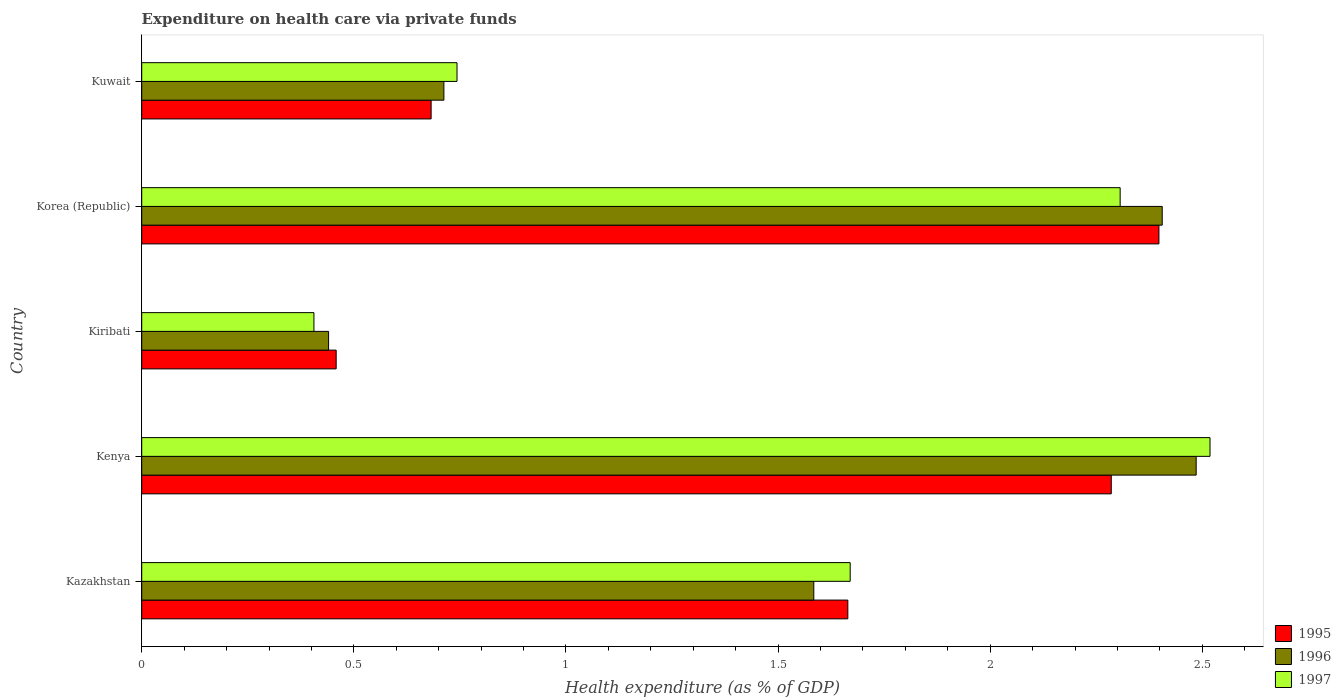How many bars are there on the 2nd tick from the bottom?
Your answer should be very brief. 3. What is the label of the 5th group of bars from the top?
Your answer should be very brief. Kazakhstan. In how many cases, is the number of bars for a given country not equal to the number of legend labels?
Your answer should be very brief. 0. What is the expenditure made on health care in 1997 in Kuwait?
Your response must be concise. 0.74. Across all countries, what is the maximum expenditure made on health care in 1995?
Your answer should be very brief. 2.4. Across all countries, what is the minimum expenditure made on health care in 1997?
Your answer should be compact. 0.41. In which country was the expenditure made on health care in 1996 maximum?
Your answer should be very brief. Kenya. In which country was the expenditure made on health care in 1995 minimum?
Offer a terse response. Kiribati. What is the total expenditure made on health care in 1996 in the graph?
Your answer should be compact. 7.63. What is the difference between the expenditure made on health care in 1996 in Kiribati and that in Kuwait?
Make the answer very short. -0.27. What is the difference between the expenditure made on health care in 1997 in Kazakhstan and the expenditure made on health care in 1995 in Kenya?
Your response must be concise. -0.62. What is the average expenditure made on health care in 1996 per country?
Offer a terse response. 1.53. What is the difference between the expenditure made on health care in 1995 and expenditure made on health care in 1996 in Kazakhstan?
Your answer should be very brief. 0.08. What is the ratio of the expenditure made on health care in 1996 in Korea (Republic) to that in Kuwait?
Your answer should be compact. 3.38. What is the difference between the highest and the second highest expenditure made on health care in 1997?
Ensure brevity in your answer.  0.21. What is the difference between the highest and the lowest expenditure made on health care in 1996?
Your response must be concise. 2.04. What does the 1st bar from the top in Kazakhstan represents?
Give a very brief answer. 1997. Are all the bars in the graph horizontal?
Give a very brief answer. Yes. What is the difference between two consecutive major ticks on the X-axis?
Keep it short and to the point. 0.5. Are the values on the major ticks of X-axis written in scientific E-notation?
Keep it short and to the point. No. Does the graph contain any zero values?
Provide a short and direct response. No. What is the title of the graph?
Your response must be concise. Expenditure on health care via private funds. What is the label or title of the X-axis?
Your answer should be compact. Health expenditure (as % of GDP). What is the Health expenditure (as % of GDP) in 1995 in Kazakhstan?
Your response must be concise. 1.66. What is the Health expenditure (as % of GDP) of 1996 in Kazakhstan?
Provide a short and direct response. 1.58. What is the Health expenditure (as % of GDP) of 1997 in Kazakhstan?
Offer a very short reply. 1.67. What is the Health expenditure (as % of GDP) of 1995 in Kenya?
Provide a succinct answer. 2.29. What is the Health expenditure (as % of GDP) in 1996 in Kenya?
Provide a succinct answer. 2.49. What is the Health expenditure (as % of GDP) in 1997 in Kenya?
Ensure brevity in your answer.  2.52. What is the Health expenditure (as % of GDP) in 1995 in Kiribati?
Make the answer very short. 0.46. What is the Health expenditure (as % of GDP) of 1996 in Kiribati?
Provide a succinct answer. 0.44. What is the Health expenditure (as % of GDP) of 1997 in Kiribati?
Keep it short and to the point. 0.41. What is the Health expenditure (as % of GDP) of 1995 in Korea (Republic)?
Provide a succinct answer. 2.4. What is the Health expenditure (as % of GDP) in 1996 in Korea (Republic)?
Your response must be concise. 2.41. What is the Health expenditure (as % of GDP) in 1997 in Korea (Republic)?
Ensure brevity in your answer.  2.31. What is the Health expenditure (as % of GDP) of 1995 in Kuwait?
Ensure brevity in your answer.  0.68. What is the Health expenditure (as % of GDP) in 1996 in Kuwait?
Your answer should be very brief. 0.71. What is the Health expenditure (as % of GDP) of 1997 in Kuwait?
Your answer should be very brief. 0.74. Across all countries, what is the maximum Health expenditure (as % of GDP) in 1995?
Give a very brief answer. 2.4. Across all countries, what is the maximum Health expenditure (as % of GDP) of 1996?
Your answer should be compact. 2.49. Across all countries, what is the maximum Health expenditure (as % of GDP) in 1997?
Your answer should be very brief. 2.52. Across all countries, what is the minimum Health expenditure (as % of GDP) of 1995?
Keep it short and to the point. 0.46. Across all countries, what is the minimum Health expenditure (as % of GDP) of 1996?
Provide a short and direct response. 0.44. Across all countries, what is the minimum Health expenditure (as % of GDP) of 1997?
Make the answer very short. 0.41. What is the total Health expenditure (as % of GDP) in 1995 in the graph?
Your answer should be very brief. 7.49. What is the total Health expenditure (as % of GDP) of 1996 in the graph?
Your response must be concise. 7.63. What is the total Health expenditure (as % of GDP) in 1997 in the graph?
Keep it short and to the point. 7.64. What is the difference between the Health expenditure (as % of GDP) of 1995 in Kazakhstan and that in Kenya?
Your response must be concise. -0.62. What is the difference between the Health expenditure (as % of GDP) of 1996 in Kazakhstan and that in Kenya?
Ensure brevity in your answer.  -0.9. What is the difference between the Health expenditure (as % of GDP) of 1997 in Kazakhstan and that in Kenya?
Your answer should be very brief. -0.85. What is the difference between the Health expenditure (as % of GDP) of 1995 in Kazakhstan and that in Kiribati?
Offer a terse response. 1.21. What is the difference between the Health expenditure (as % of GDP) in 1996 in Kazakhstan and that in Kiribati?
Make the answer very short. 1.14. What is the difference between the Health expenditure (as % of GDP) in 1997 in Kazakhstan and that in Kiribati?
Provide a succinct answer. 1.26. What is the difference between the Health expenditure (as % of GDP) of 1995 in Kazakhstan and that in Korea (Republic)?
Provide a short and direct response. -0.73. What is the difference between the Health expenditure (as % of GDP) in 1996 in Kazakhstan and that in Korea (Republic)?
Ensure brevity in your answer.  -0.82. What is the difference between the Health expenditure (as % of GDP) in 1997 in Kazakhstan and that in Korea (Republic)?
Your answer should be compact. -0.64. What is the difference between the Health expenditure (as % of GDP) of 1995 in Kazakhstan and that in Kuwait?
Offer a terse response. 0.98. What is the difference between the Health expenditure (as % of GDP) in 1996 in Kazakhstan and that in Kuwait?
Make the answer very short. 0.87. What is the difference between the Health expenditure (as % of GDP) of 1997 in Kazakhstan and that in Kuwait?
Offer a very short reply. 0.93. What is the difference between the Health expenditure (as % of GDP) in 1995 in Kenya and that in Kiribati?
Provide a succinct answer. 1.83. What is the difference between the Health expenditure (as % of GDP) of 1996 in Kenya and that in Kiribati?
Provide a succinct answer. 2.04. What is the difference between the Health expenditure (as % of GDP) in 1997 in Kenya and that in Kiribati?
Your response must be concise. 2.11. What is the difference between the Health expenditure (as % of GDP) of 1995 in Kenya and that in Korea (Republic)?
Offer a terse response. -0.11. What is the difference between the Health expenditure (as % of GDP) of 1997 in Kenya and that in Korea (Republic)?
Make the answer very short. 0.21. What is the difference between the Health expenditure (as % of GDP) in 1995 in Kenya and that in Kuwait?
Keep it short and to the point. 1.6. What is the difference between the Health expenditure (as % of GDP) of 1996 in Kenya and that in Kuwait?
Provide a short and direct response. 1.77. What is the difference between the Health expenditure (as % of GDP) in 1997 in Kenya and that in Kuwait?
Provide a succinct answer. 1.77. What is the difference between the Health expenditure (as % of GDP) in 1995 in Kiribati and that in Korea (Republic)?
Offer a very short reply. -1.94. What is the difference between the Health expenditure (as % of GDP) of 1996 in Kiribati and that in Korea (Republic)?
Your answer should be compact. -1.96. What is the difference between the Health expenditure (as % of GDP) in 1997 in Kiribati and that in Korea (Republic)?
Ensure brevity in your answer.  -1.9. What is the difference between the Health expenditure (as % of GDP) in 1995 in Kiribati and that in Kuwait?
Your answer should be very brief. -0.22. What is the difference between the Health expenditure (as % of GDP) of 1996 in Kiribati and that in Kuwait?
Your answer should be very brief. -0.27. What is the difference between the Health expenditure (as % of GDP) of 1997 in Kiribati and that in Kuwait?
Keep it short and to the point. -0.34. What is the difference between the Health expenditure (as % of GDP) in 1995 in Korea (Republic) and that in Kuwait?
Offer a terse response. 1.72. What is the difference between the Health expenditure (as % of GDP) of 1996 in Korea (Republic) and that in Kuwait?
Provide a short and direct response. 1.69. What is the difference between the Health expenditure (as % of GDP) of 1997 in Korea (Republic) and that in Kuwait?
Your answer should be compact. 1.56. What is the difference between the Health expenditure (as % of GDP) of 1995 in Kazakhstan and the Health expenditure (as % of GDP) of 1996 in Kenya?
Provide a short and direct response. -0.82. What is the difference between the Health expenditure (as % of GDP) of 1995 in Kazakhstan and the Health expenditure (as % of GDP) of 1997 in Kenya?
Your answer should be very brief. -0.85. What is the difference between the Health expenditure (as % of GDP) of 1996 in Kazakhstan and the Health expenditure (as % of GDP) of 1997 in Kenya?
Keep it short and to the point. -0.93. What is the difference between the Health expenditure (as % of GDP) of 1995 in Kazakhstan and the Health expenditure (as % of GDP) of 1996 in Kiribati?
Your answer should be very brief. 1.22. What is the difference between the Health expenditure (as % of GDP) of 1995 in Kazakhstan and the Health expenditure (as % of GDP) of 1997 in Kiribati?
Provide a succinct answer. 1.26. What is the difference between the Health expenditure (as % of GDP) in 1996 in Kazakhstan and the Health expenditure (as % of GDP) in 1997 in Kiribati?
Keep it short and to the point. 1.18. What is the difference between the Health expenditure (as % of GDP) in 1995 in Kazakhstan and the Health expenditure (as % of GDP) in 1996 in Korea (Republic)?
Offer a very short reply. -0.74. What is the difference between the Health expenditure (as % of GDP) in 1995 in Kazakhstan and the Health expenditure (as % of GDP) in 1997 in Korea (Republic)?
Your response must be concise. -0.64. What is the difference between the Health expenditure (as % of GDP) of 1996 in Kazakhstan and the Health expenditure (as % of GDP) of 1997 in Korea (Republic)?
Your response must be concise. -0.72. What is the difference between the Health expenditure (as % of GDP) in 1995 in Kazakhstan and the Health expenditure (as % of GDP) in 1996 in Kuwait?
Offer a terse response. 0.95. What is the difference between the Health expenditure (as % of GDP) of 1995 in Kazakhstan and the Health expenditure (as % of GDP) of 1997 in Kuwait?
Your answer should be compact. 0.92. What is the difference between the Health expenditure (as % of GDP) in 1996 in Kazakhstan and the Health expenditure (as % of GDP) in 1997 in Kuwait?
Ensure brevity in your answer.  0.84. What is the difference between the Health expenditure (as % of GDP) in 1995 in Kenya and the Health expenditure (as % of GDP) in 1996 in Kiribati?
Make the answer very short. 1.84. What is the difference between the Health expenditure (as % of GDP) in 1995 in Kenya and the Health expenditure (as % of GDP) in 1997 in Kiribati?
Keep it short and to the point. 1.88. What is the difference between the Health expenditure (as % of GDP) in 1996 in Kenya and the Health expenditure (as % of GDP) in 1997 in Kiribati?
Your answer should be very brief. 2.08. What is the difference between the Health expenditure (as % of GDP) of 1995 in Kenya and the Health expenditure (as % of GDP) of 1996 in Korea (Republic)?
Offer a very short reply. -0.12. What is the difference between the Health expenditure (as % of GDP) of 1995 in Kenya and the Health expenditure (as % of GDP) of 1997 in Korea (Republic)?
Provide a succinct answer. -0.02. What is the difference between the Health expenditure (as % of GDP) in 1996 in Kenya and the Health expenditure (as % of GDP) in 1997 in Korea (Republic)?
Offer a very short reply. 0.18. What is the difference between the Health expenditure (as % of GDP) in 1995 in Kenya and the Health expenditure (as % of GDP) in 1996 in Kuwait?
Your answer should be compact. 1.57. What is the difference between the Health expenditure (as % of GDP) of 1995 in Kenya and the Health expenditure (as % of GDP) of 1997 in Kuwait?
Offer a terse response. 1.54. What is the difference between the Health expenditure (as % of GDP) in 1996 in Kenya and the Health expenditure (as % of GDP) in 1997 in Kuwait?
Offer a very short reply. 1.74. What is the difference between the Health expenditure (as % of GDP) of 1995 in Kiribati and the Health expenditure (as % of GDP) of 1996 in Korea (Republic)?
Your answer should be compact. -1.95. What is the difference between the Health expenditure (as % of GDP) in 1995 in Kiribati and the Health expenditure (as % of GDP) in 1997 in Korea (Republic)?
Offer a very short reply. -1.85. What is the difference between the Health expenditure (as % of GDP) of 1996 in Kiribati and the Health expenditure (as % of GDP) of 1997 in Korea (Republic)?
Ensure brevity in your answer.  -1.87. What is the difference between the Health expenditure (as % of GDP) of 1995 in Kiribati and the Health expenditure (as % of GDP) of 1996 in Kuwait?
Your response must be concise. -0.25. What is the difference between the Health expenditure (as % of GDP) of 1995 in Kiribati and the Health expenditure (as % of GDP) of 1997 in Kuwait?
Your answer should be compact. -0.28. What is the difference between the Health expenditure (as % of GDP) of 1996 in Kiribati and the Health expenditure (as % of GDP) of 1997 in Kuwait?
Your answer should be very brief. -0.3. What is the difference between the Health expenditure (as % of GDP) in 1995 in Korea (Republic) and the Health expenditure (as % of GDP) in 1996 in Kuwait?
Provide a succinct answer. 1.69. What is the difference between the Health expenditure (as % of GDP) in 1995 in Korea (Republic) and the Health expenditure (as % of GDP) in 1997 in Kuwait?
Make the answer very short. 1.65. What is the difference between the Health expenditure (as % of GDP) of 1996 in Korea (Republic) and the Health expenditure (as % of GDP) of 1997 in Kuwait?
Provide a succinct answer. 1.66. What is the average Health expenditure (as % of GDP) in 1995 per country?
Your response must be concise. 1.5. What is the average Health expenditure (as % of GDP) in 1996 per country?
Your response must be concise. 1.53. What is the average Health expenditure (as % of GDP) in 1997 per country?
Your response must be concise. 1.53. What is the difference between the Health expenditure (as % of GDP) in 1995 and Health expenditure (as % of GDP) in 1996 in Kazakhstan?
Your response must be concise. 0.08. What is the difference between the Health expenditure (as % of GDP) in 1995 and Health expenditure (as % of GDP) in 1997 in Kazakhstan?
Provide a succinct answer. -0.01. What is the difference between the Health expenditure (as % of GDP) of 1996 and Health expenditure (as % of GDP) of 1997 in Kazakhstan?
Offer a terse response. -0.09. What is the difference between the Health expenditure (as % of GDP) of 1995 and Health expenditure (as % of GDP) of 1996 in Kenya?
Your answer should be very brief. -0.2. What is the difference between the Health expenditure (as % of GDP) of 1995 and Health expenditure (as % of GDP) of 1997 in Kenya?
Offer a very short reply. -0.23. What is the difference between the Health expenditure (as % of GDP) in 1996 and Health expenditure (as % of GDP) in 1997 in Kenya?
Make the answer very short. -0.03. What is the difference between the Health expenditure (as % of GDP) of 1995 and Health expenditure (as % of GDP) of 1996 in Kiribati?
Your response must be concise. 0.02. What is the difference between the Health expenditure (as % of GDP) in 1995 and Health expenditure (as % of GDP) in 1997 in Kiribati?
Your answer should be compact. 0.05. What is the difference between the Health expenditure (as % of GDP) in 1996 and Health expenditure (as % of GDP) in 1997 in Kiribati?
Give a very brief answer. 0.03. What is the difference between the Health expenditure (as % of GDP) of 1995 and Health expenditure (as % of GDP) of 1996 in Korea (Republic)?
Offer a very short reply. -0.01. What is the difference between the Health expenditure (as % of GDP) of 1995 and Health expenditure (as % of GDP) of 1997 in Korea (Republic)?
Ensure brevity in your answer.  0.09. What is the difference between the Health expenditure (as % of GDP) in 1996 and Health expenditure (as % of GDP) in 1997 in Korea (Republic)?
Offer a very short reply. 0.1. What is the difference between the Health expenditure (as % of GDP) in 1995 and Health expenditure (as % of GDP) in 1996 in Kuwait?
Offer a very short reply. -0.03. What is the difference between the Health expenditure (as % of GDP) of 1995 and Health expenditure (as % of GDP) of 1997 in Kuwait?
Provide a succinct answer. -0.06. What is the difference between the Health expenditure (as % of GDP) in 1996 and Health expenditure (as % of GDP) in 1997 in Kuwait?
Keep it short and to the point. -0.03. What is the ratio of the Health expenditure (as % of GDP) of 1995 in Kazakhstan to that in Kenya?
Give a very brief answer. 0.73. What is the ratio of the Health expenditure (as % of GDP) in 1996 in Kazakhstan to that in Kenya?
Keep it short and to the point. 0.64. What is the ratio of the Health expenditure (as % of GDP) in 1997 in Kazakhstan to that in Kenya?
Give a very brief answer. 0.66. What is the ratio of the Health expenditure (as % of GDP) of 1995 in Kazakhstan to that in Kiribati?
Offer a very short reply. 3.63. What is the ratio of the Health expenditure (as % of GDP) of 1996 in Kazakhstan to that in Kiribati?
Ensure brevity in your answer.  3.6. What is the ratio of the Health expenditure (as % of GDP) of 1997 in Kazakhstan to that in Kiribati?
Offer a terse response. 4.11. What is the ratio of the Health expenditure (as % of GDP) of 1995 in Kazakhstan to that in Korea (Republic)?
Your answer should be compact. 0.69. What is the ratio of the Health expenditure (as % of GDP) in 1996 in Kazakhstan to that in Korea (Republic)?
Make the answer very short. 0.66. What is the ratio of the Health expenditure (as % of GDP) of 1997 in Kazakhstan to that in Korea (Republic)?
Provide a succinct answer. 0.72. What is the ratio of the Health expenditure (as % of GDP) in 1995 in Kazakhstan to that in Kuwait?
Provide a short and direct response. 2.44. What is the ratio of the Health expenditure (as % of GDP) in 1996 in Kazakhstan to that in Kuwait?
Your response must be concise. 2.22. What is the ratio of the Health expenditure (as % of GDP) of 1997 in Kazakhstan to that in Kuwait?
Your answer should be compact. 2.25. What is the ratio of the Health expenditure (as % of GDP) of 1995 in Kenya to that in Kiribati?
Your answer should be compact. 4.99. What is the ratio of the Health expenditure (as % of GDP) of 1996 in Kenya to that in Kiribati?
Make the answer very short. 5.64. What is the ratio of the Health expenditure (as % of GDP) of 1997 in Kenya to that in Kiribati?
Your answer should be compact. 6.2. What is the ratio of the Health expenditure (as % of GDP) of 1995 in Kenya to that in Korea (Republic)?
Offer a very short reply. 0.95. What is the ratio of the Health expenditure (as % of GDP) of 1997 in Kenya to that in Korea (Republic)?
Provide a succinct answer. 1.09. What is the ratio of the Health expenditure (as % of GDP) in 1995 in Kenya to that in Kuwait?
Ensure brevity in your answer.  3.35. What is the ratio of the Health expenditure (as % of GDP) of 1996 in Kenya to that in Kuwait?
Provide a short and direct response. 3.49. What is the ratio of the Health expenditure (as % of GDP) in 1997 in Kenya to that in Kuwait?
Give a very brief answer. 3.39. What is the ratio of the Health expenditure (as % of GDP) in 1995 in Kiribati to that in Korea (Republic)?
Give a very brief answer. 0.19. What is the ratio of the Health expenditure (as % of GDP) of 1996 in Kiribati to that in Korea (Republic)?
Offer a terse response. 0.18. What is the ratio of the Health expenditure (as % of GDP) of 1997 in Kiribati to that in Korea (Republic)?
Provide a short and direct response. 0.18. What is the ratio of the Health expenditure (as % of GDP) of 1995 in Kiribati to that in Kuwait?
Give a very brief answer. 0.67. What is the ratio of the Health expenditure (as % of GDP) in 1996 in Kiribati to that in Kuwait?
Provide a succinct answer. 0.62. What is the ratio of the Health expenditure (as % of GDP) of 1997 in Kiribati to that in Kuwait?
Offer a very short reply. 0.55. What is the ratio of the Health expenditure (as % of GDP) in 1995 in Korea (Republic) to that in Kuwait?
Provide a succinct answer. 3.51. What is the ratio of the Health expenditure (as % of GDP) in 1996 in Korea (Republic) to that in Kuwait?
Make the answer very short. 3.38. What is the ratio of the Health expenditure (as % of GDP) in 1997 in Korea (Republic) to that in Kuwait?
Offer a terse response. 3.1. What is the difference between the highest and the second highest Health expenditure (as % of GDP) of 1995?
Make the answer very short. 0.11. What is the difference between the highest and the second highest Health expenditure (as % of GDP) in 1996?
Your answer should be very brief. 0.08. What is the difference between the highest and the second highest Health expenditure (as % of GDP) of 1997?
Give a very brief answer. 0.21. What is the difference between the highest and the lowest Health expenditure (as % of GDP) of 1995?
Your answer should be very brief. 1.94. What is the difference between the highest and the lowest Health expenditure (as % of GDP) in 1996?
Provide a succinct answer. 2.04. What is the difference between the highest and the lowest Health expenditure (as % of GDP) in 1997?
Your answer should be very brief. 2.11. 